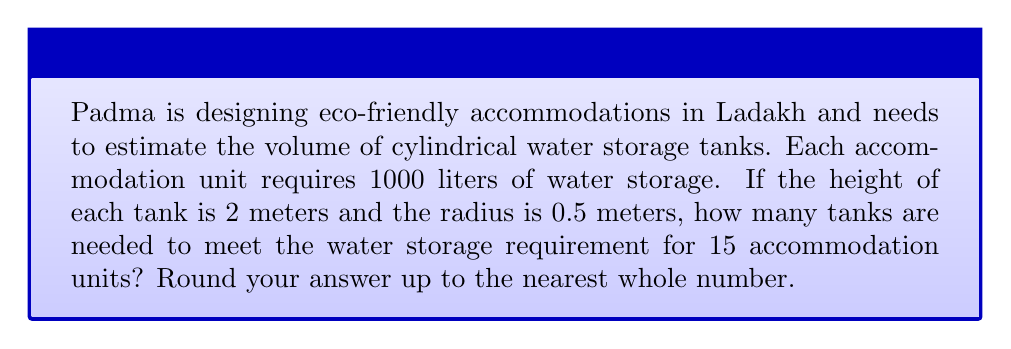Teach me how to tackle this problem. Let's approach this problem step by step:

1) First, we need to calculate the volume of one cylindrical tank.
   The formula for the volume of a cylinder is:
   $$V = \pi r^2 h$$
   where $r$ is the radius and $h$ is the height.

2) Given:
   Radius $(r) = 0.5$ meters
   Height $(h) = 2$ meters

3) Let's substitute these values into the formula:
   $$V = \pi (0.5\text{ m})^2 (2\text{ m})$$
   $$V = \pi (0.25\text{ m}^2) (2\text{ m})$$
   $$V = 0.5\pi\text{ m}^3$$

4) Now, let's calculate this:
   $$V \approx 1.5708\text{ m}^3$$

5) We need to convert this to liters:
   1 m³ = 1000 liters
   So, $1.5708\text{ m}^3 = 1570.8$ liters

6) Each accommodation unit requires 1000 liters, and there are 15 units.
   Total water required = $1000\text{ L} \times 15 = 15000\text{ L}$

7) Number of tanks needed:
   $$\frac{15000\text{ L}}{1570.8\text{ L per tank}} \approx 9.55\text{ tanks}$$

8) Rounding up to the nearest whole number: 10 tanks
Answer: 10 tanks 